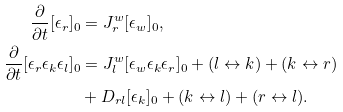<formula> <loc_0><loc_0><loc_500><loc_500>\frac { \partial } { \partial t } [ \epsilon _ { r } ] _ { 0 } & = J _ { r } ^ { w } [ \epsilon _ { w } ] _ { 0 } , \\ \frac { \partial } { \partial t } [ \epsilon _ { r } \epsilon _ { k } \epsilon _ { l } ] _ { 0 } & = J _ { l } ^ { w } [ \epsilon _ { w } \epsilon _ { k } \epsilon _ { r } ] _ { 0 } + ( l \leftrightarrow k ) + ( k \leftrightarrow r ) \\ & + D _ { r l } [ \epsilon _ { k } ] _ { 0 } + ( k \leftrightarrow l ) + ( r \leftrightarrow l ) .</formula> 